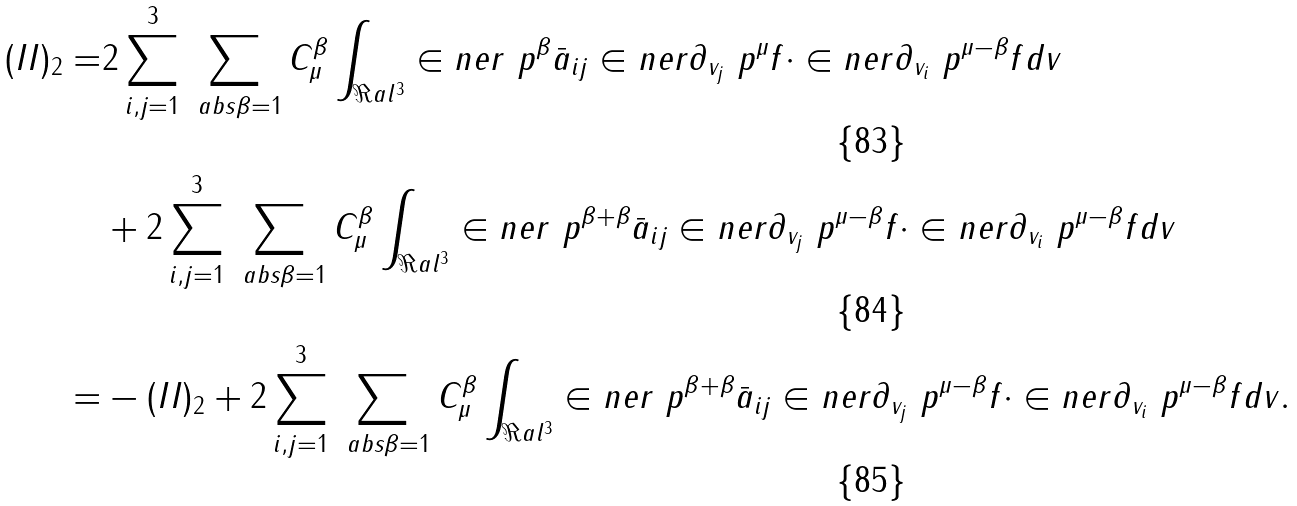<formula> <loc_0><loc_0><loc_500><loc_500>( I I ) _ { 2 } = & 2 \sum _ { i , j = 1 } ^ { 3 } \sum _ { \ a b s \beta = 1 } C _ { \mu } ^ { \beta } \int _ { \Re a l ^ { 3 } } \in n e r { \ p ^ { \beta } \bar { a } _ { i j } } \in n e r { \partial _ { v _ { j } } \ p ^ { \mu } f } \cdot \in n e r { \partial _ { v _ { i } } \ p ^ { \mu - \beta } f } d v \\ & + 2 \sum _ { i , j = 1 } ^ { 3 } \sum _ { \ a b s \beta = 1 } C _ { \mu } ^ { \beta } \int _ { \Re a l ^ { 3 } } \in n e r { \ p ^ { \beta + \beta } \bar { a } _ { i j } } \in n e r { \partial _ { v _ { j } } \ p ^ { \mu - \beta } f } \cdot \in n e r { \partial _ { v _ { i } } \ p ^ { \mu - \beta } f } d v \\ = & - ( I I ) _ { 2 } + 2 \sum _ { i , j = 1 } ^ { 3 } \sum _ { \ a b s \beta = 1 } C _ { \mu } ^ { \beta } \int _ { \Re a l ^ { 3 } } \in n e r { \ p ^ { \beta + \beta } \bar { a } _ { i j } } \in n e r { \partial _ { v _ { j } } \ p ^ { \mu - \beta } f } \cdot \in n e r { \partial _ { v _ { i } } \ p ^ { \mu - \beta } f } d v .</formula> 